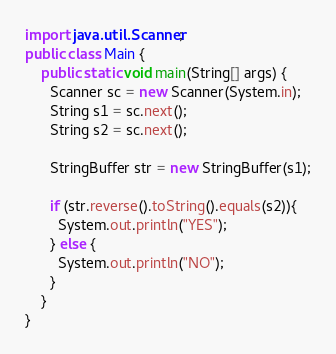<code> <loc_0><loc_0><loc_500><loc_500><_Java_>import java.util.Scanner;
public class Main {
	public static void main(String[] args) {
      Scanner sc = new Scanner(System.in);
      String s1 = sc.next();
      String s2 = sc.next();
      
      StringBuffer str = new StringBuffer(s1);
      
      if (str.reverse().toString().equals(s2)){
        System.out.println("YES");
      } else {
        System.out.println("NO");
      }
    }
}</code> 